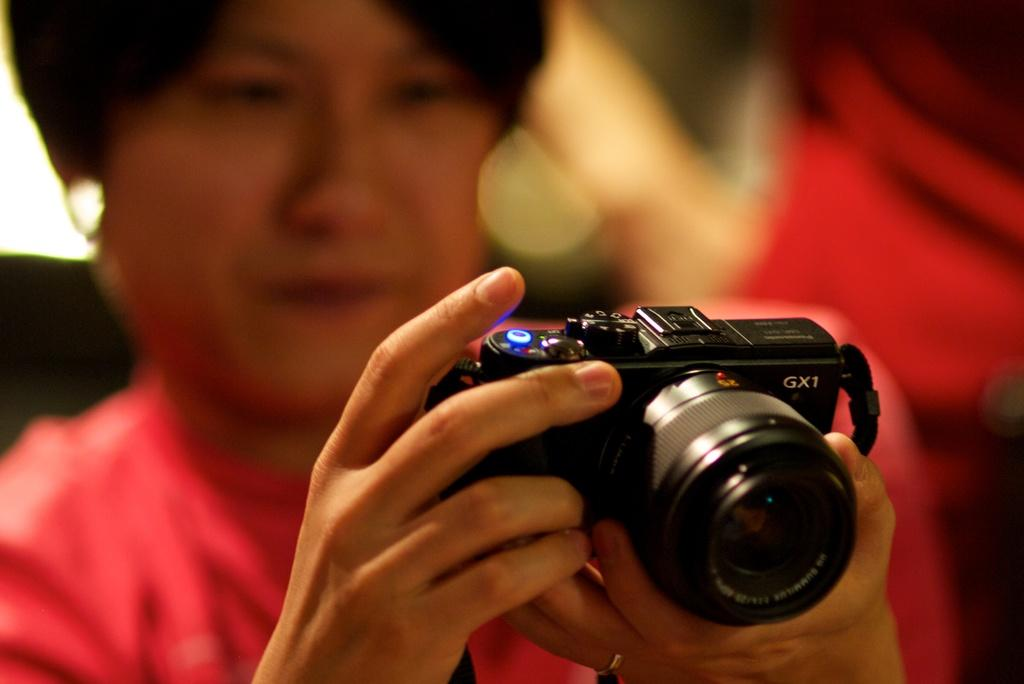What is the main subject of the image? There is a person in the image. What is the person holding in the image? The person is holding a camera. Can you tell me how many errors the person is fixing in the image? There is no indication of any errors in the image, as it features a person holding a camera. Is the person in the image giving a magic kiss to someone? There is no indication of a kiss or any magical element in the image. 